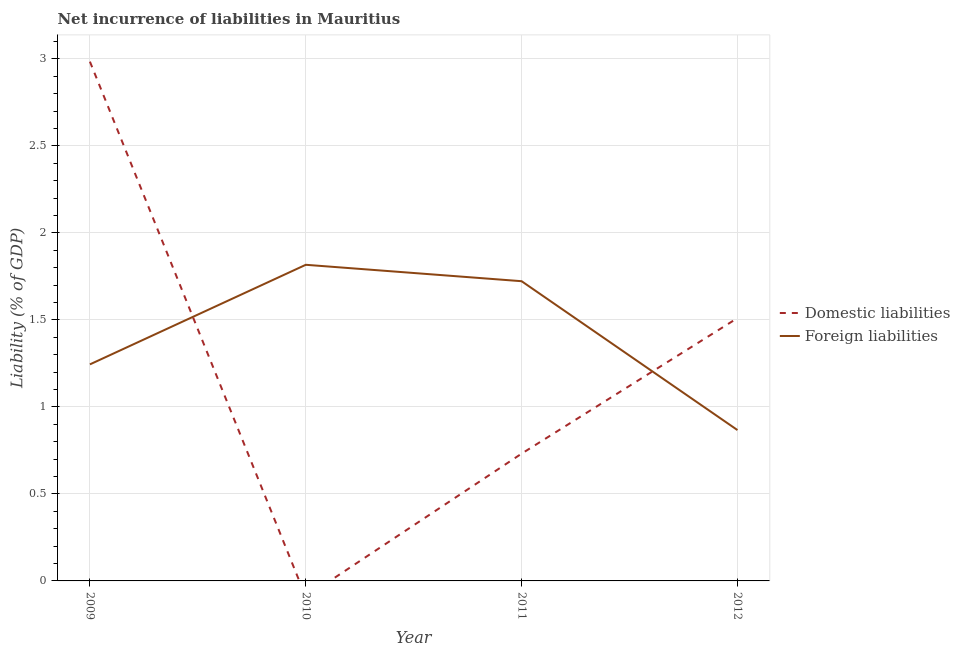What is the incurrence of domestic liabilities in 2012?
Your response must be concise. 1.51. Across all years, what is the maximum incurrence of domestic liabilities?
Keep it short and to the point. 2.98. Across all years, what is the minimum incurrence of foreign liabilities?
Offer a very short reply. 0.87. In which year was the incurrence of foreign liabilities maximum?
Provide a succinct answer. 2010. What is the total incurrence of foreign liabilities in the graph?
Make the answer very short. 5.65. What is the difference between the incurrence of foreign liabilities in 2009 and that in 2012?
Provide a short and direct response. 0.38. What is the difference between the incurrence of foreign liabilities in 2012 and the incurrence of domestic liabilities in 2010?
Ensure brevity in your answer.  0.87. What is the average incurrence of foreign liabilities per year?
Make the answer very short. 1.41. In the year 2011, what is the difference between the incurrence of domestic liabilities and incurrence of foreign liabilities?
Make the answer very short. -0.99. What is the ratio of the incurrence of foreign liabilities in 2009 to that in 2011?
Make the answer very short. 0.72. Is the incurrence of foreign liabilities in 2009 less than that in 2012?
Give a very brief answer. No. Is the difference between the incurrence of domestic liabilities in 2009 and 2011 greater than the difference between the incurrence of foreign liabilities in 2009 and 2011?
Offer a terse response. Yes. What is the difference between the highest and the second highest incurrence of domestic liabilities?
Provide a succinct answer. 1.47. What is the difference between the highest and the lowest incurrence of foreign liabilities?
Your response must be concise. 0.95. In how many years, is the incurrence of domestic liabilities greater than the average incurrence of domestic liabilities taken over all years?
Your response must be concise. 2. Is the incurrence of domestic liabilities strictly less than the incurrence of foreign liabilities over the years?
Keep it short and to the point. No. How many lines are there?
Provide a succinct answer. 2. How many years are there in the graph?
Keep it short and to the point. 4. Are the values on the major ticks of Y-axis written in scientific E-notation?
Offer a terse response. No. Does the graph contain any zero values?
Offer a terse response. Yes. Does the graph contain grids?
Offer a very short reply. Yes. Where does the legend appear in the graph?
Your response must be concise. Center right. How many legend labels are there?
Give a very brief answer. 2. How are the legend labels stacked?
Provide a succinct answer. Vertical. What is the title of the graph?
Your response must be concise. Net incurrence of liabilities in Mauritius. What is the label or title of the X-axis?
Offer a very short reply. Year. What is the label or title of the Y-axis?
Make the answer very short. Liability (% of GDP). What is the Liability (% of GDP) of Domestic liabilities in 2009?
Provide a short and direct response. 2.98. What is the Liability (% of GDP) in Foreign liabilities in 2009?
Offer a very short reply. 1.24. What is the Liability (% of GDP) in Domestic liabilities in 2010?
Your response must be concise. 0. What is the Liability (% of GDP) of Foreign liabilities in 2010?
Your response must be concise. 1.82. What is the Liability (% of GDP) of Domestic liabilities in 2011?
Your answer should be compact. 0.73. What is the Liability (% of GDP) in Foreign liabilities in 2011?
Make the answer very short. 1.72. What is the Liability (% of GDP) in Domestic liabilities in 2012?
Offer a very short reply. 1.51. What is the Liability (% of GDP) in Foreign liabilities in 2012?
Ensure brevity in your answer.  0.87. Across all years, what is the maximum Liability (% of GDP) in Domestic liabilities?
Your answer should be compact. 2.98. Across all years, what is the maximum Liability (% of GDP) in Foreign liabilities?
Provide a succinct answer. 1.82. Across all years, what is the minimum Liability (% of GDP) in Foreign liabilities?
Your answer should be compact. 0.87. What is the total Liability (% of GDP) of Domestic liabilities in the graph?
Your answer should be compact. 5.23. What is the total Liability (% of GDP) of Foreign liabilities in the graph?
Offer a very short reply. 5.65. What is the difference between the Liability (% of GDP) of Foreign liabilities in 2009 and that in 2010?
Give a very brief answer. -0.57. What is the difference between the Liability (% of GDP) of Domestic liabilities in 2009 and that in 2011?
Provide a short and direct response. 2.25. What is the difference between the Liability (% of GDP) of Foreign liabilities in 2009 and that in 2011?
Provide a short and direct response. -0.48. What is the difference between the Liability (% of GDP) of Domestic liabilities in 2009 and that in 2012?
Your answer should be compact. 1.47. What is the difference between the Liability (% of GDP) in Foreign liabilities in 2009 and that in 2012?
Ensure brevity in your answer.  0.38. What is the difference between the Liability (% of GDP) of Foreign liabilities in 2010 and that in 2011?
Keep it short and to the point. 0.09. What is the difference between the Liability (% of GDP) in Foreign liabilities in 2010 and that in 2012?
Your answer should be very brief. 0.95. What is the difference between the Liability (% of GDP) in Domestic liabilities in 2011 and that in 2012?
Your answer should be very brief. -0.78. What is the difference between the Liability (% of GDP) of Foreign liabilities in 2011 and that in 2012?
Your response must be concise. 0.86. What is the difference between the Liability (% of GDP) of Domestic liabilities in 2009 and the Liability (% of GDP) of Foreign liabilities in 2010?
Ensure brevity in your answer.  1.17. What is the difference between the Liability (% of GDP) of Domestic liabilities in 2009 and the Liability (% of GDP) of Foreign liabilities in 2011?
Your answer should be very brief. 1.26. What is the difference between the Liability (% of GDP) of Domestic liabilities in 2009 and the Liability (% of GDP) of Foreign liabilities in 2012?
Offer a terse response. 2.12. What is the difference between the Liability (% of GDP) in Domestic liabilities in 2011 and the Liability (% of GDP) in Foreign liabilities in 2012?
Offer a terse response. -0.14. What is the average Liability (% of GDP) in Domestic liabilities per year?
Make the answer very short. 1.31. What is the average Liability (% of GDP) of Foreign liabilities per year?
Give a very brief answer. 1.41. In the year 2009, what is the difference between the Liability (% of GDP) of Domestic liabilities and Liability (% of GDP) of Foreign liabilities?
Ensure brevity in your answer.  1.74. In the year 2011, what is the difference between the Liability (% of GDP) in Domestic liabilities and Liability (% of GDP) in Foreign liabilities?
Provide a short and direct response. -0.99. In the year 2012, what is the difference between the Liability (% of GDP) in Domestic liabilities and Liability (% of GDP) in Foreign liabilities?
Offer a very short reply. 0.64. What is the ratio of the Liability (% of GDP) in Foreign liabilities in 2009 to that in 2010?
Your response must be concise. 0.69. What is the ratio of the Liability (% of GDP) of Domestic liabilities in 2009 to that in 2011?
Ensure brevity in your answer.  4.08. What is the ratio of the Liability (% of GDP) in Foreign liabilities in 2009 to that in 2011?
Keep it short and to the point. 0.72. What is the ratio of the Liability (% of GDP) in Domestic liabilities in 2009 to that in 2012?
Provide a short and direct response. 1.98. What is the ratio of the Liability (% of GDP) of Foreign liabilities in 2009 to that in 2012?
Provide a succinct answer. 1.44. What is the ratio of the Liability (% of GDP) in Foreign liabilities in 2010 to that in 2011?
Provide a succinct answer. 1.05. What is the ratio of the Liability (% of GDP) in Foreign liabilities in 2010 to that in 2012?
Offer a very short reply. 2.1. What is the ratio of the Liability (% of GDP) in Domestic liabilities in 2011 to that in 2012?
Give a very brief answer. 0.48. What is the ratio of the Liability (% of GDP) of Foreign liabilities in 2011 to that in 2012?
Make the answer very short. 1.99. What is the difference between the highest and the second highest Liability (% of GDP) in Domestic liabilities?
Give a very brief answer. 1.47. What is the difference between the highest and the second highest Liability (% of GDP) in Foreign liabilities?
Ensure brevity in your answer.  0.09. What is the difference between the highest and the lowest Liability (% of GDP) in Domestic liabilities?
Offer a very short reply. 2.98. What is the difference between the highest and the lowest Liability (% of GDP) in Foreign liabilities?
Give a very brief answer. 0.95. 